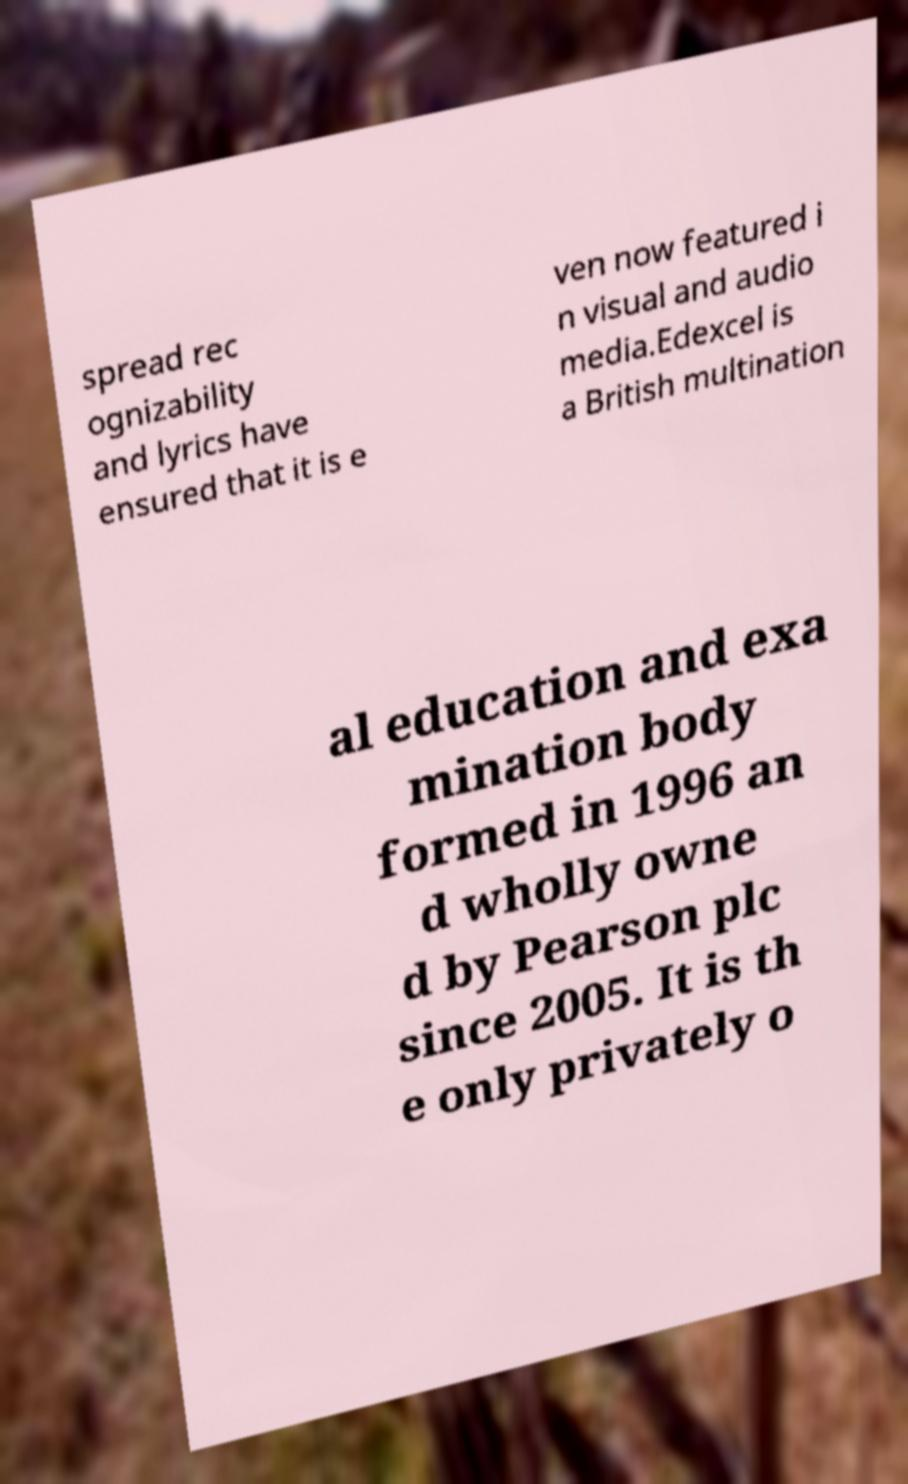Could you extract and type out the text from this image? spread rec ognizability and lyrics have ensured that it is e ven now featured i n visual and audio media.Edexcel is a British multination al education and exa mination body formed in 1996 an d wholly owne d by Pearson plc since 2005. It is th e only privately o 